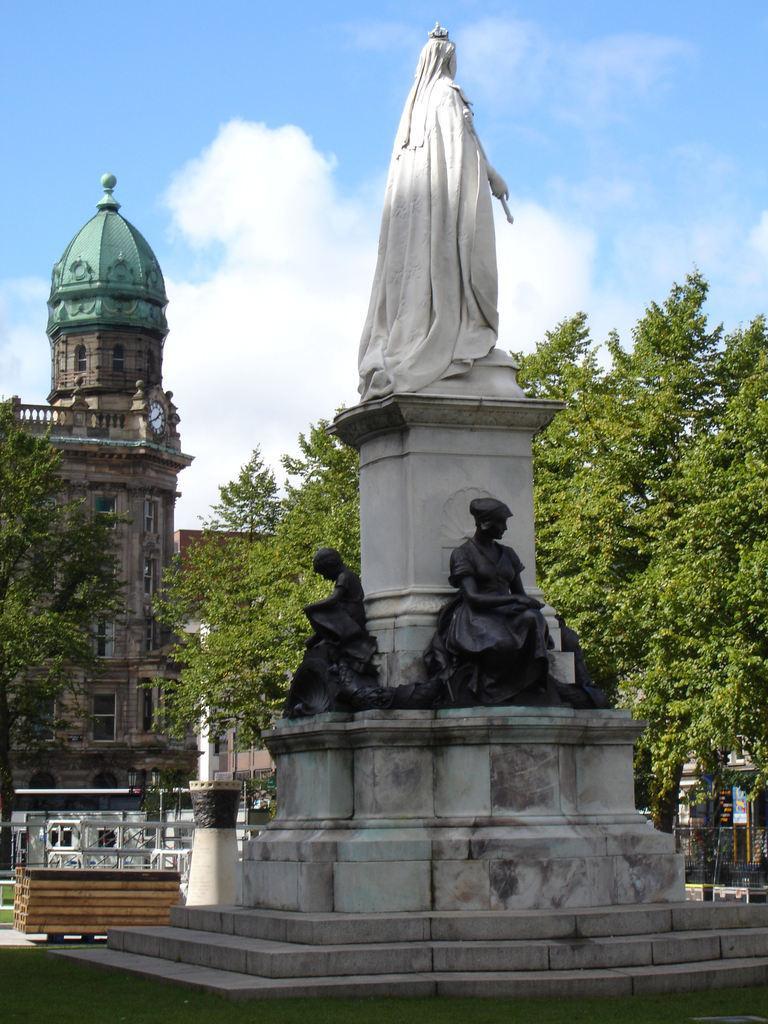Can you describe this image briefly? In this picture we can see many statues surrounded by grass, trees & buildings. The sky is blue. 